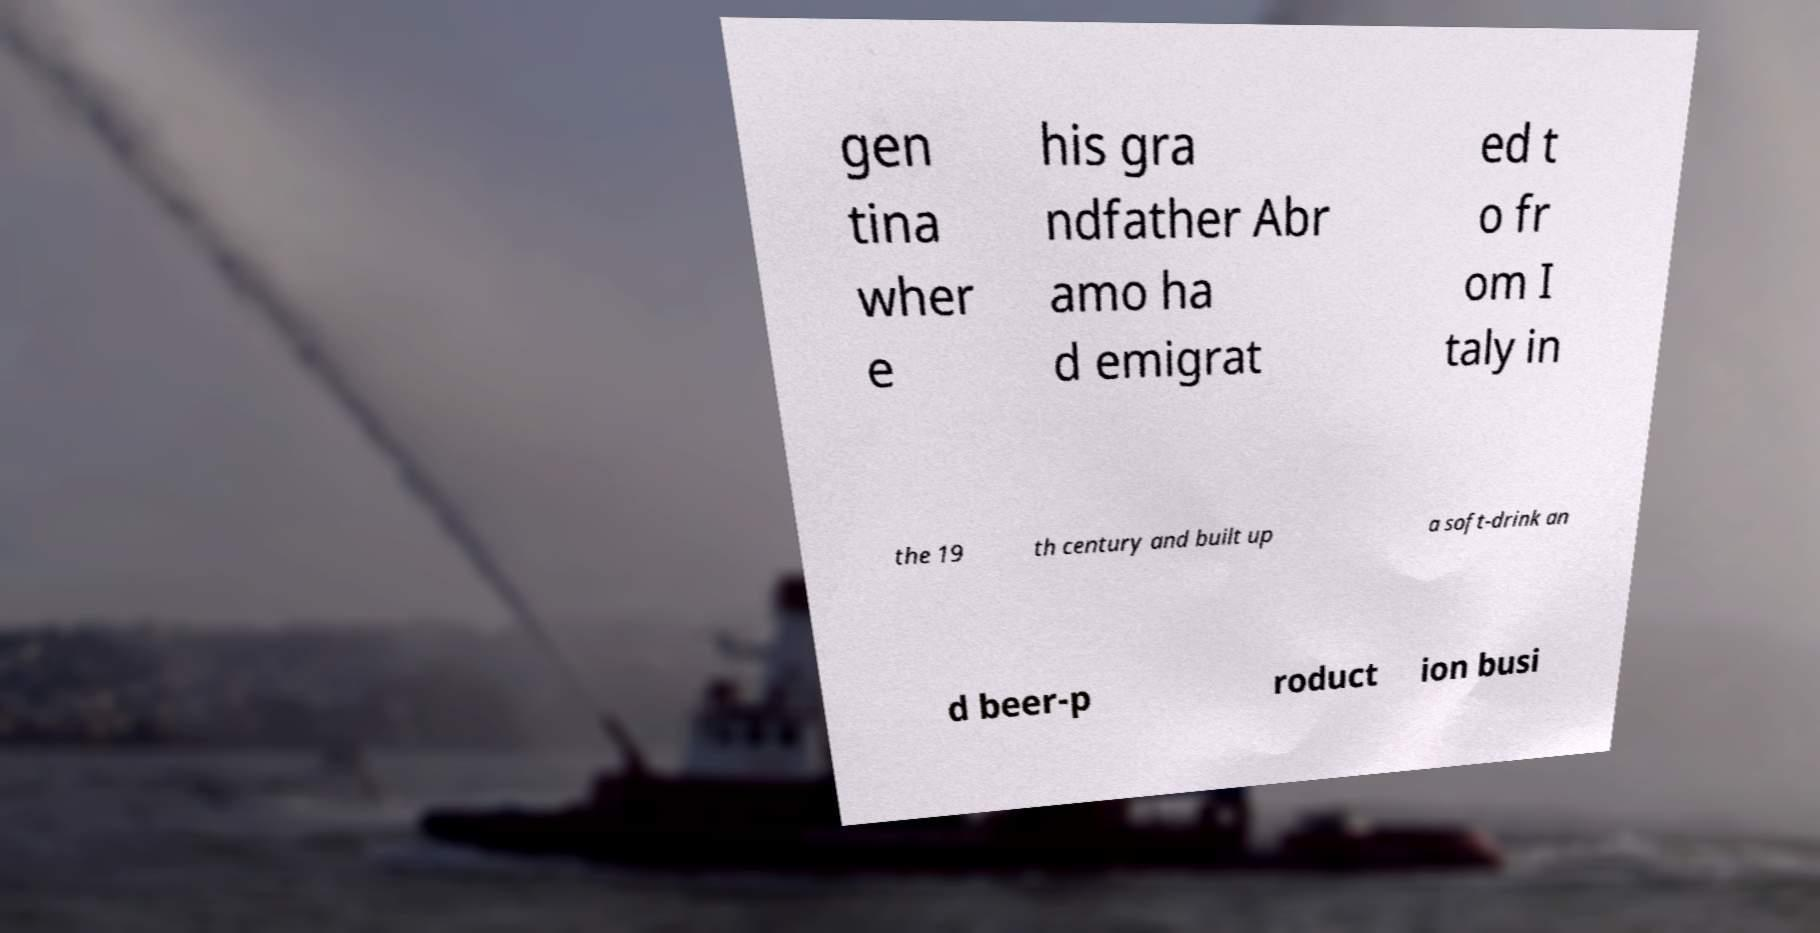I need the written content from this picture converted into text. Can you do that? gen tina wher e his gra ndfather Abr amo ha d emigrat ed t o fr om I taly in the 19 th century and built up a soft-drink an d beer-p roduct ion busi 